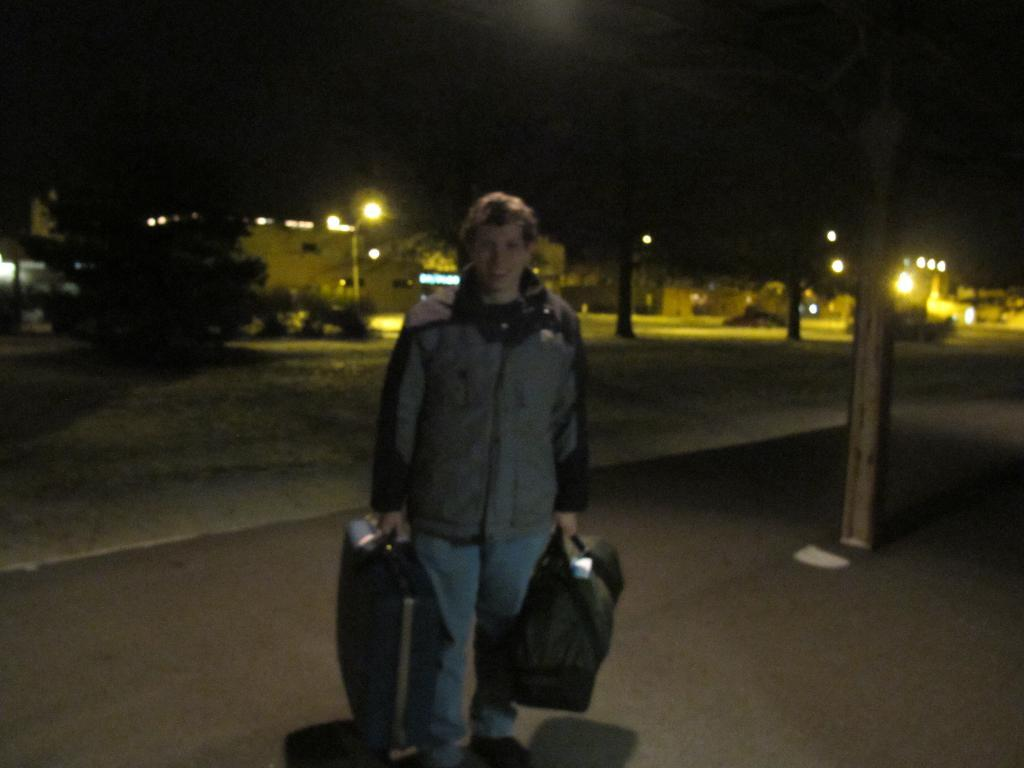What is the main subject of the image? There is a person standing in the image. What is the person wearing? The person is wearing clothes. What is the person holding in the image? The person is holding luggage bags. What can be seen in the background of the image? There is a road, poles, a tree, lights, and a dark sky visible in the image. What type of pie is being served on the box in the image? There is no box or pie present in the image. What star can be seen shining brightly in the image? There are no stars visible in the image, as the sky is dark. 